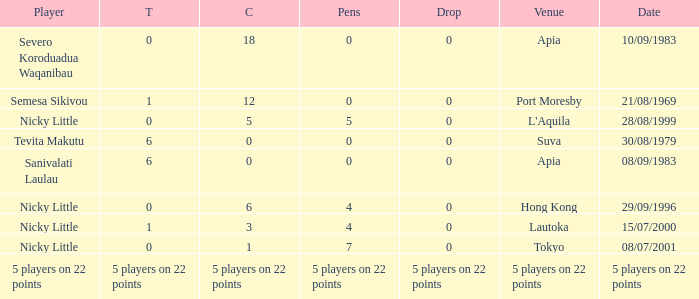How many conversions did Severo Koroduadua Waqanibau have when he has 0 pens? 18.0. 